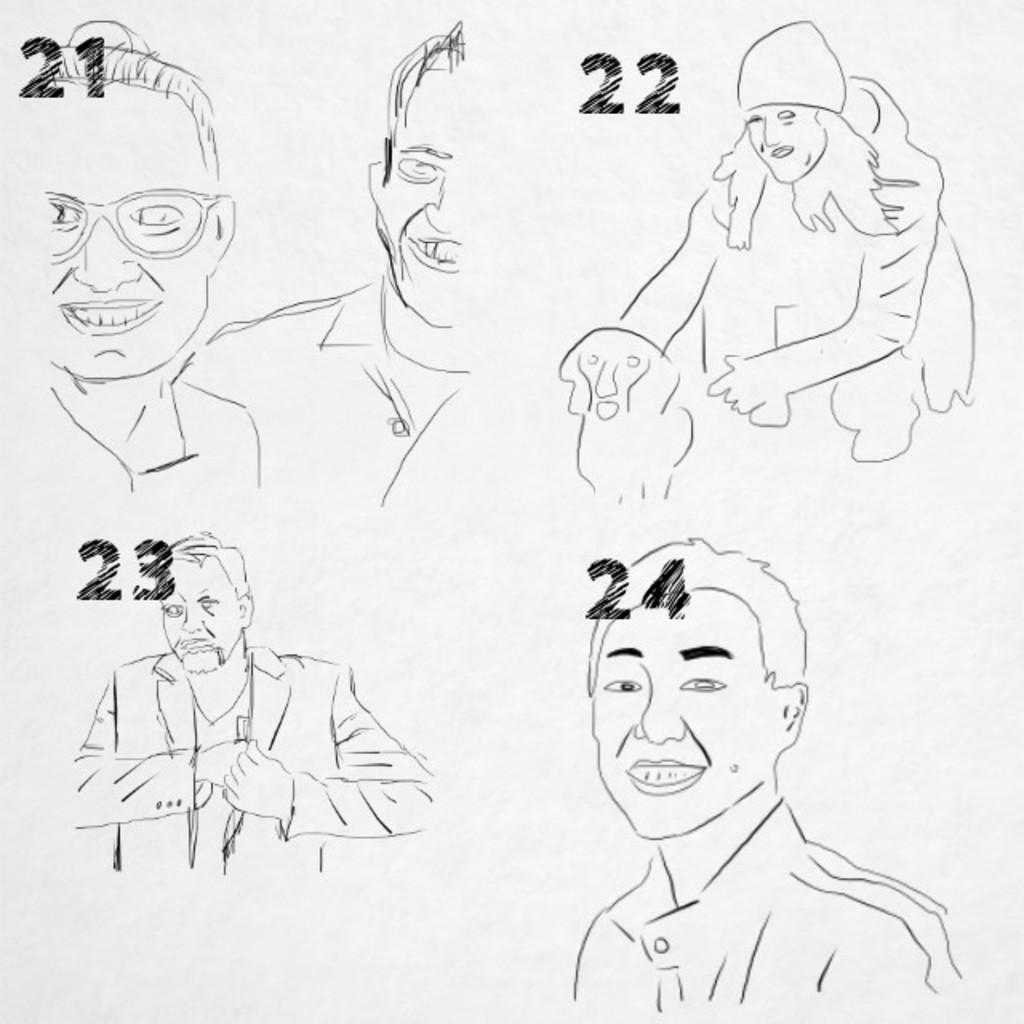Describe this image in one or two sentences. In this image there is a sketch of a few persons and a dog. 